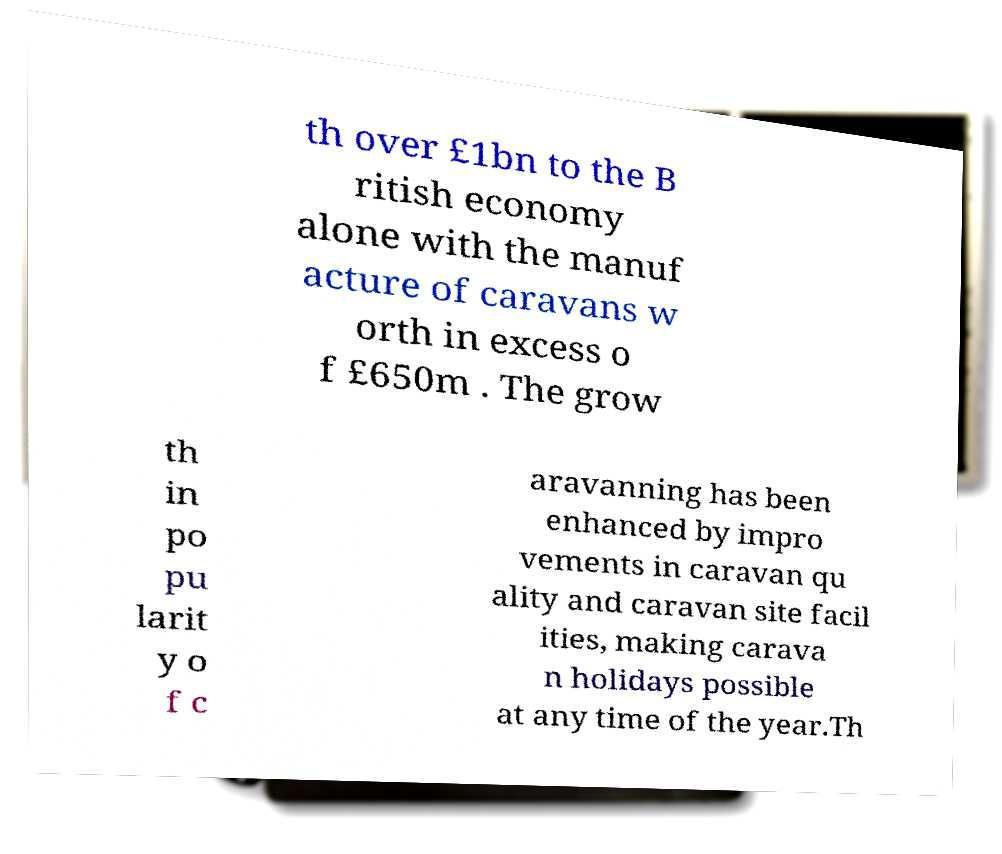For documentation purposes, I need the text within this image transcribed. Could you provide that? th over £1bn to the B ritish economy alone with the manuf acture of caravans w orth in excess o f £650m . The grow th in po pu larit y o f c aravanning has been enhanced by impro vements in caravan qu ality and caravan site facil ities, making carava n holidays possible at any time of the year.Th 